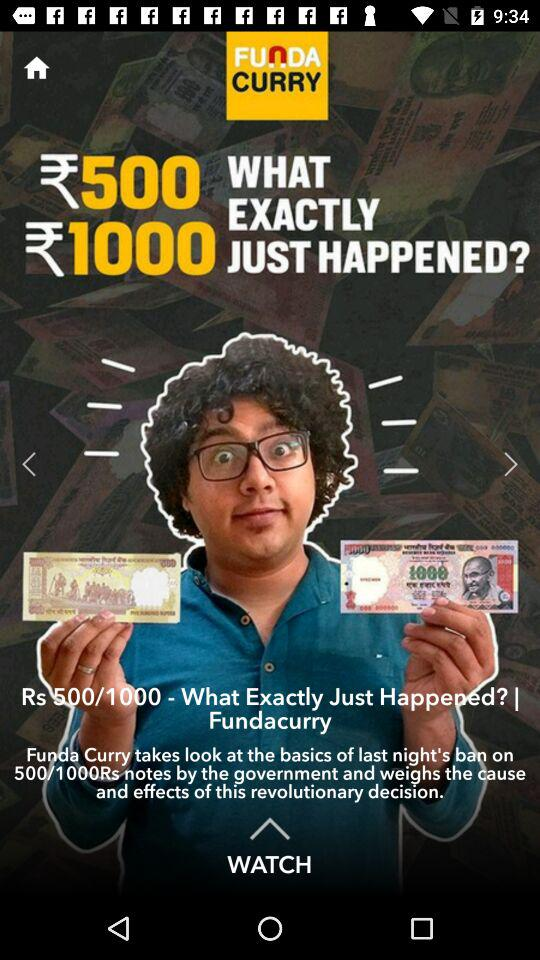When was the article "Rs 500/1000 - What Exactly Just Happened?" posted?
When the provided information is insufficient, respond with <no answer>. <no answer> 